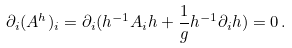<formula> <loc_0><loc_0><loc_500><loc_500>\partial _ { i } ( A ^ { h } ) _ { i } = \partial _ { i } ( h ^ { - 1 } A _ { i } h + \frac { 1 } { g } h ^ { - 1 } \partial _ { i } h ) = 0 \, .</formula> 